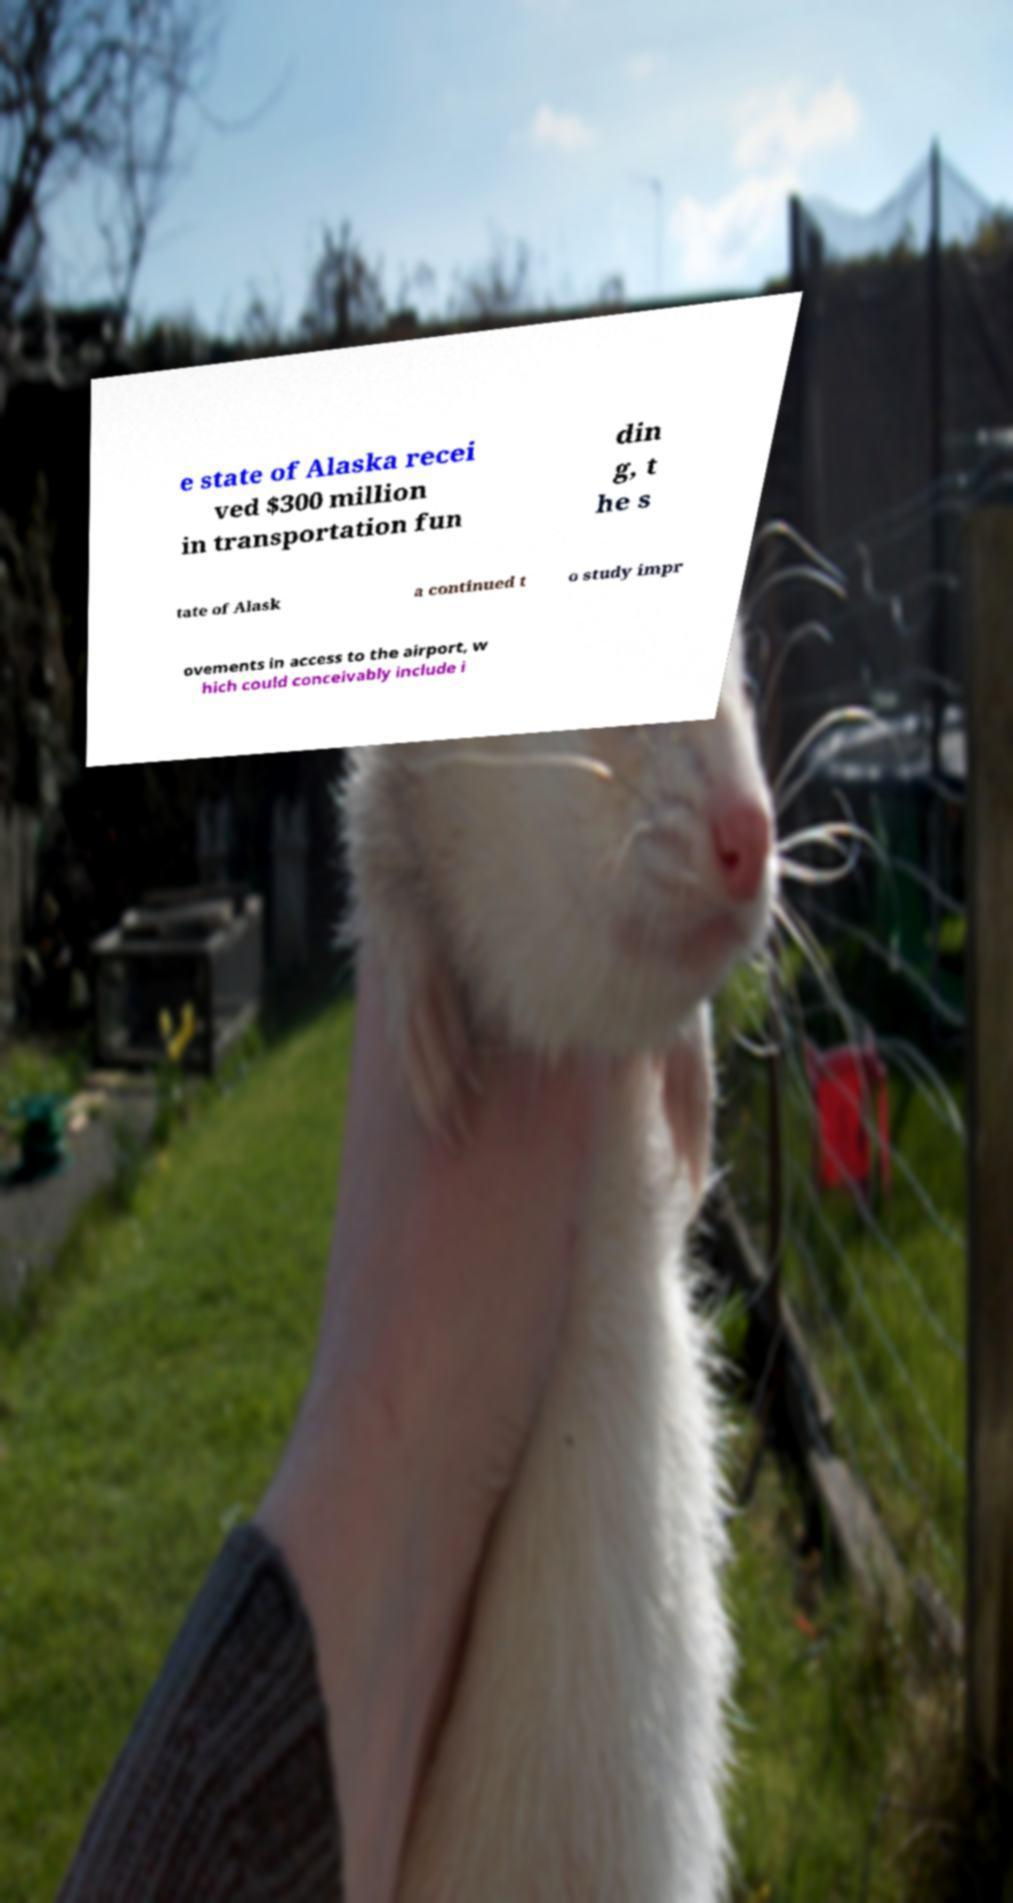Can you read and provide the text displayed in the image?This photo seems to have some interesting text. Can you extract and type it out for me? e state of Alaska recei ved $300 million in transportation fun din g, t he s tate of Alask a continued t o study impr ovements in access to the airport, w hich could conceivably include i 